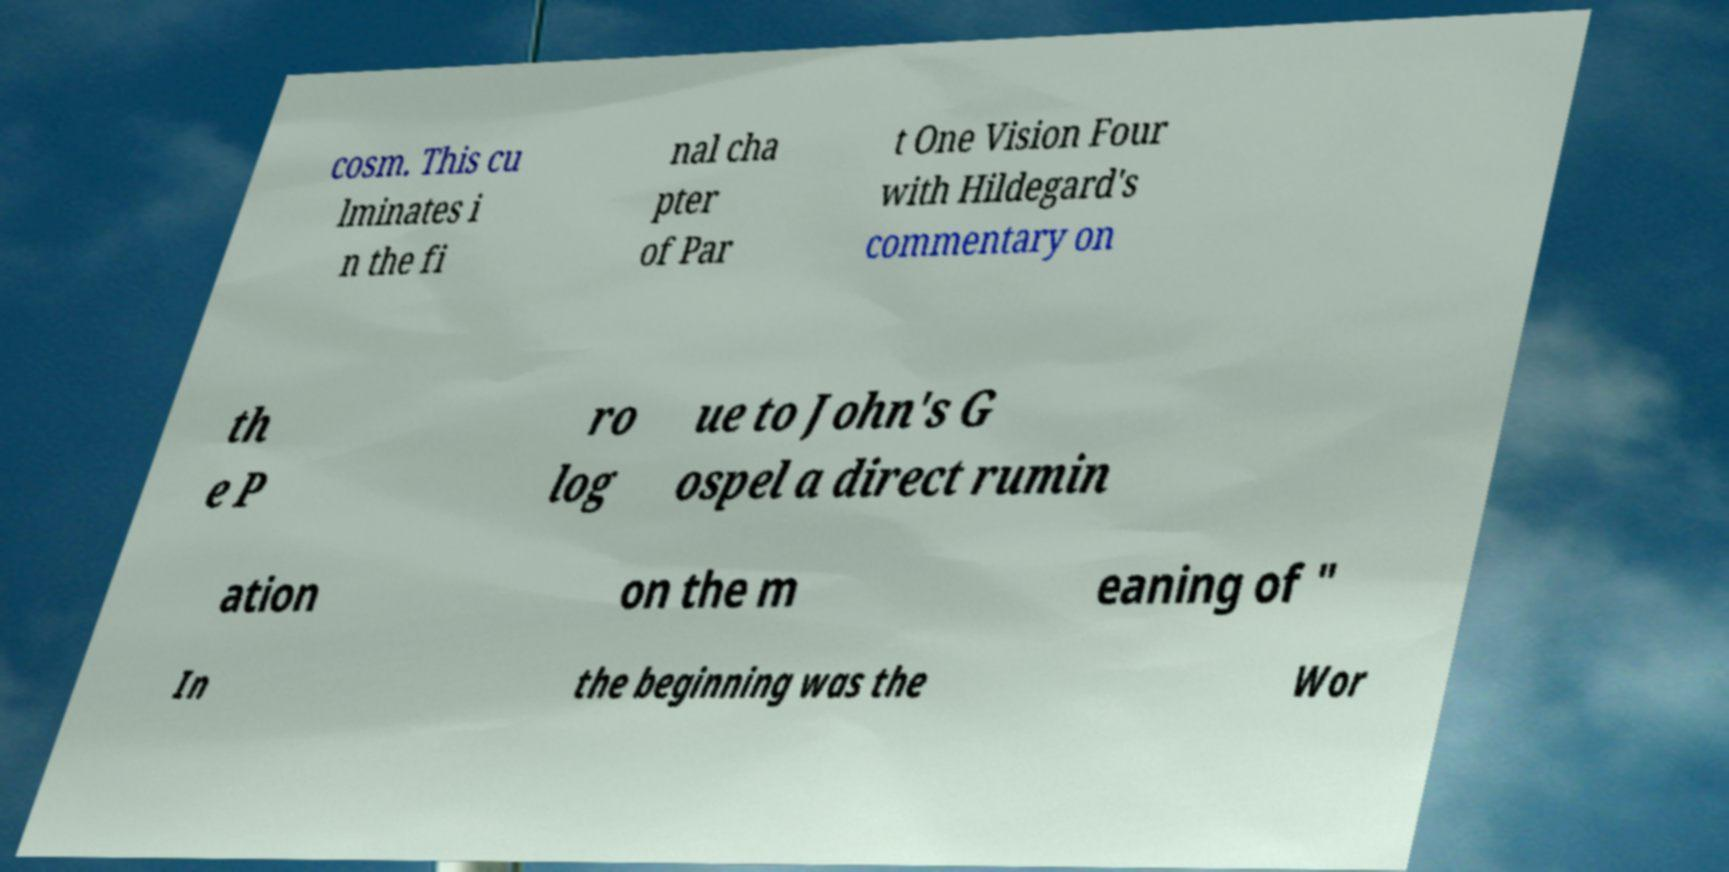I need the written content from this picture converted into text. Can you do that? cosm. This cu lminates i n the fi nal cha pter of Par t One Vision Four with Hildegard's commentary on th e P ro log ue to John's G ospel a direct rumin ation on the m eaning of " In the beginning was the Wor 